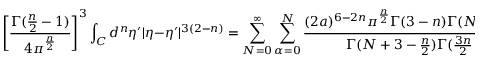<formula> <loc_0><loc_0><loc_500><loc_500>\left [ \frac { \Gamma ( \frac { n } { 2 } - 1 ) } { 4 \pi ^ { \frac { n } { 2 } } } \right ] ^ { 3 } \int _ { C } d ^ { n } \eta ^ { \prime } | \eta - \eta ^ { \prime } | ^ { 3 ( 2 - n ) } = \sum _ { N = 0 } ^ { \infty } \sum _ { \alpha = 0 } ^ { N } \frac { ( 2 a ) ^ { 6 - 2 n } { \pi } ^ { \frac { n } { 2 } } \Gamma ( 3 - n ) \Gamma ( N - 3 + \frac { 3 n } { 2 } ) } { \Gamma ( N + 3 - \frac { n } { 2 } ) \Gamma ( \frac { 3 n } { 2 } - 3 ) } Y _ { \alpha } ^ { N } ( { \eta } ) \int _ { C } d ^ { n } \eta ^ { \prime } Y _ { \alpha } ^ { N } ( \eta ^ { \prime } )</formula> 